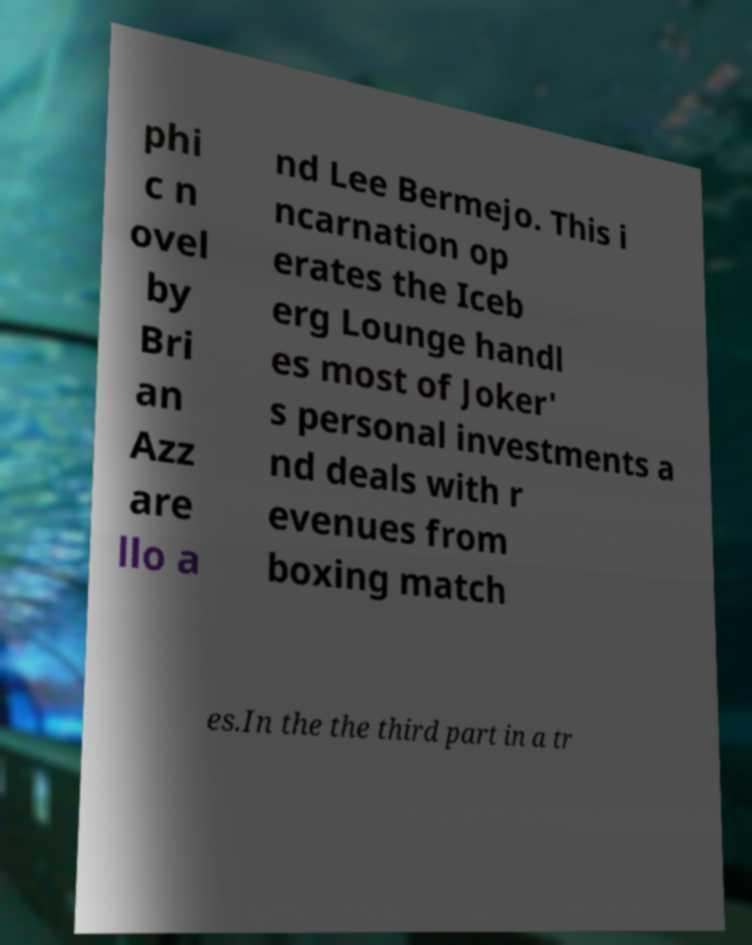Can you read and provide the text displayed in the image?This photo seems to have some interesting text. Can you extract and type it out for me? phi c n ovel by Bri an Azz are llo a nd Lee Bermejo. This i ncarnation op erates the Iceb erg Lounge handl es most of Joker' s personal investments a nd deals with r evenues from boxing match es.In the the third part in a tr 